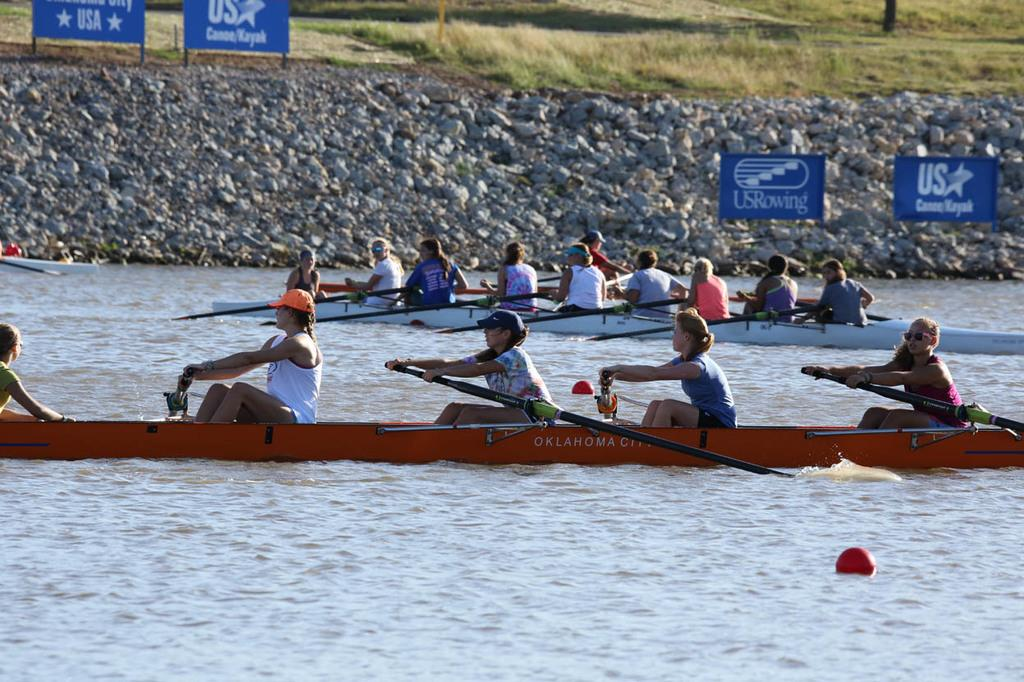What activity are the persons in the image engaged in? The persons in the image are sailing boats on the water surface. What natural features can be seen in the image? There are rocks visible in the image. Are there any signs or messages in the image? Yes, there are boards with text in the image. What type of vegetation is present on the ground? There is grass on the ground. What type of stocking is being used to lift the boats in the image? There is no stocking or lifting mechanism present in the image; the boats are being sailed on the water surface. 